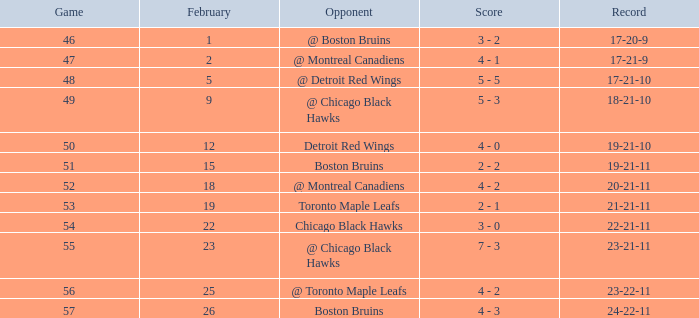What was the score of the game 57 after February 23? 4 - 3. 